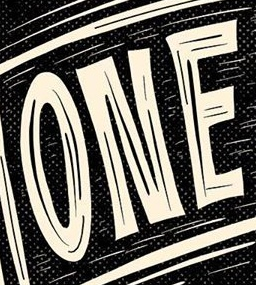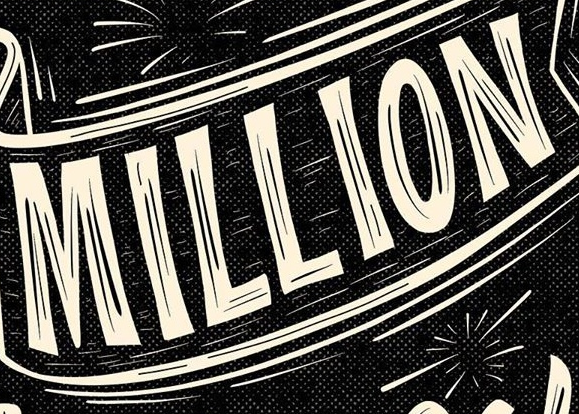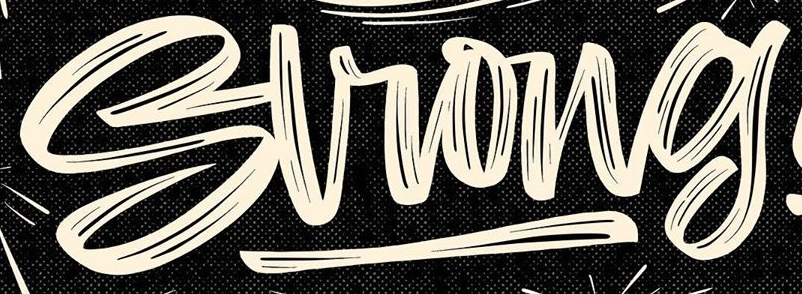What words are shown in these images in order, separated by a semicolon? ONE; MILLION; Strong 